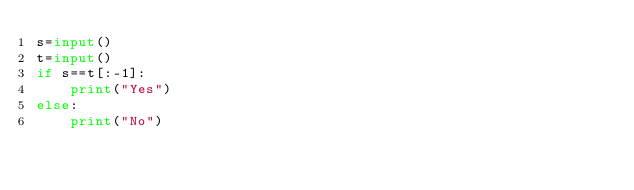<code> <loc_0><loc_0><loc_500><loc_500><_Python_>s=input()
t=input()
if s==t[:-1]:
    print("Yes")
else:
    print("No")</code> 